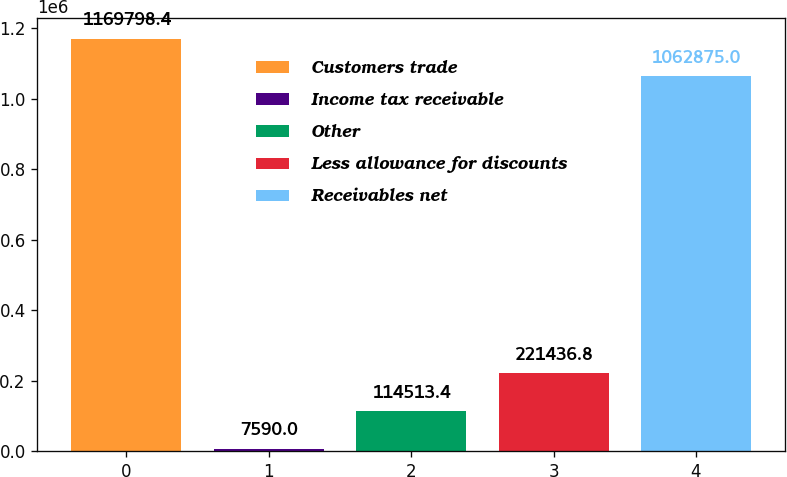<chart> <loc_0><loc_0><loc_500><loc_500><bar_chart><fcel>Customers trade<fcel>Income tax receivable<fcel>Other<fcel>Less allowance for discounts<fcel>Receivables net<nl><fcel>1.1698e+06<fcel>7590<fcel>114513<fcel>221437<fcel>1.06288e+06<nl></chart> 